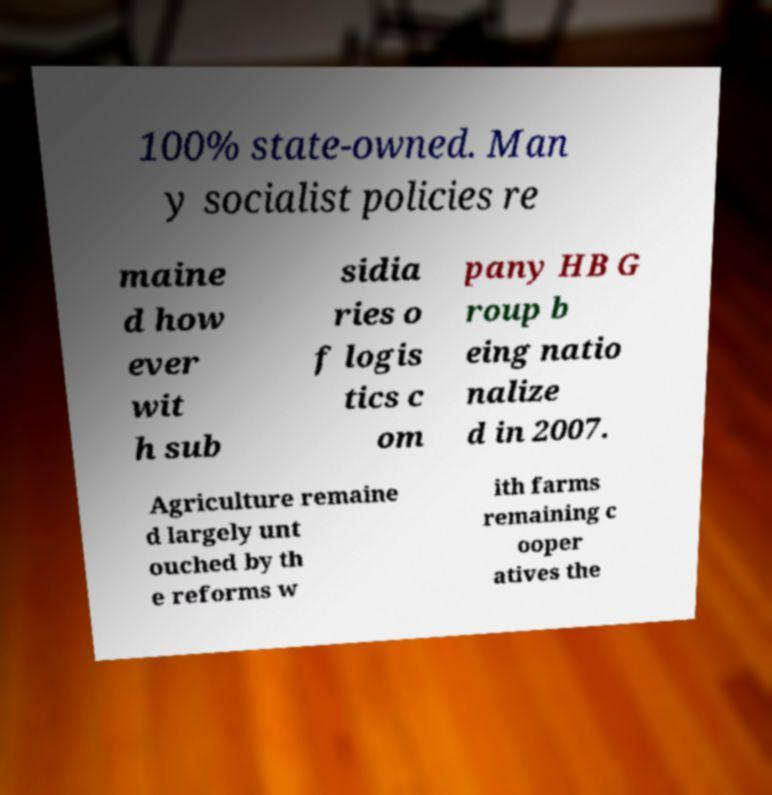Can you accurately transcribe the text from the provided image for me? 100% state-owned. Man y socialist policies re maine d how ever wit h sub sidia ries o f logis tics c om pany HB G roup b eing natio nalize d in 2007. Agriculture remaine d largely unt ouched by th e reforms w ith farms remaining c ooper atives the 